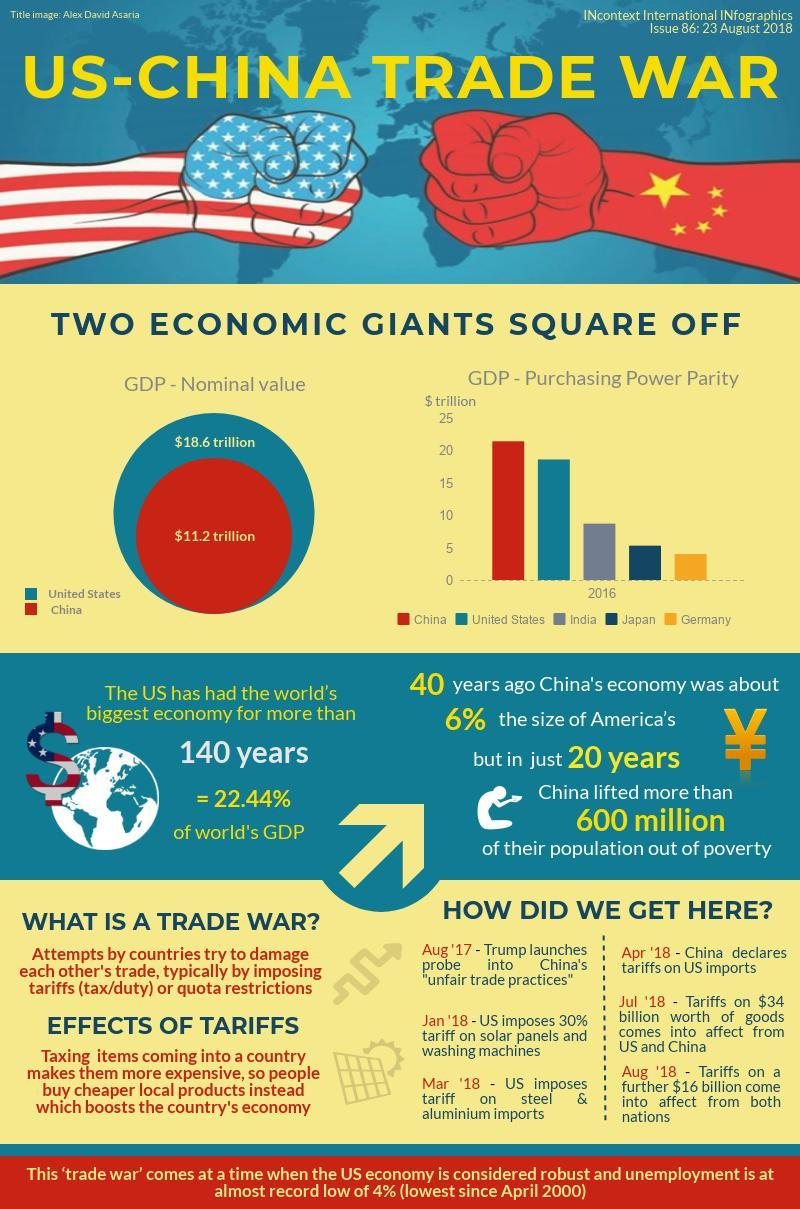How many countries are compared, with respect to their purchasing power parity, on the graph?
Answer the question with a short phrase. 5 What is the nominal GDP of the US? $18.6 trillion Which three countries have the highest PPP (purchasing power parity) GDP? China, United States, India By how much is the nominal GDP of US higher than that of China($ trillion)? 7.4 Which three countries had  a PPP GDP (purchasing power parity) less than $ 10 trillion? India, Japan, Germany Which country has a higher GDP (nominal value)? US Which two countries are trying to damage each others trade? US, China Which country had the highest Purchasing Power Parity GDP? China What percentage of the global GDP is contributed by the US? 22.44% Who was the American president who initiated investigation on 'unfair trade practices' by China? Trump How many people were lifted out of poverty in China over the last two decades? 600 million What is the nominal GDP of China? $11.2 trillion On which products did US impose tariffs first, on  Steel or solar panels? Solar panels What came first, China declaring tariffs on US imports or Trump launching probe on China's unfair trade practices? Trump launching probe on China's unfair trade practices 